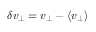Convert formula to latex. <formula><loc_0><loc_0><loc_500><loc_500>\delta v _ { \perp } = v _ { \perp } - \langle v _ { \perp } \rangle</formula> 